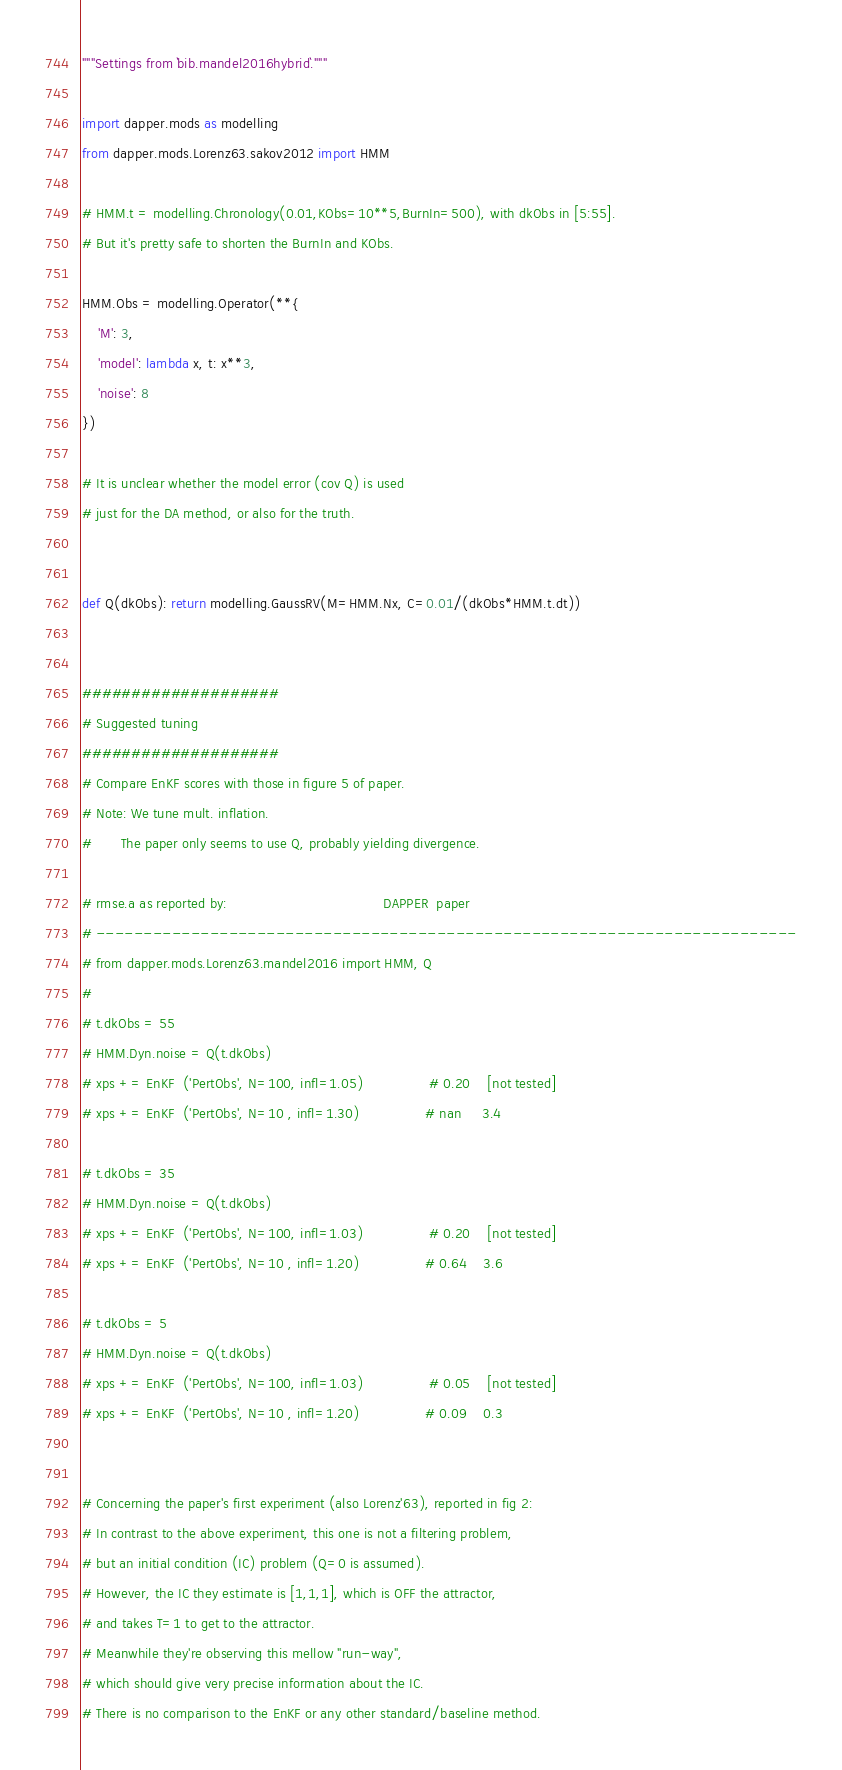Convert code to text. <code><loc_0><loc_0><loc_500><loc_500><_Python_>"""Settings from `bib.mandel2016hybrid`."""

import dapper.mods as modelling
from dapper.mods.Lorenz63.sakov2012 import HMM

# HMM.t = modelling.Chronology(0.01,KObs=10**5,BurnIn=500), with dkObs in [5:55].
# But it's pretty safe to shorten the BurnIn and KObs.

HMM.Obs = modelling.Operator(**{
    'M': 3,
    'model': lambda x, t: x**3,
    'noise': 8
})

# It is unclear whether the model error (cov Q) is used
# just for the DA method, or also for the truth.


def Q(dkObs): return modelling.GaussRV(M=HMM.Nx, C=0.01/(dkObs*HMM.t.dt))


####################
# Suggested tuning
####################
# Compare EnKF scores with those in figure 5 of paper.
# Note: We tune mult. inflation.
#       The paper only seems to use Q, probably yielding divergence.

# rmse.a as reported by:                                      DAPPER  paper
# --------------------------------------------------------------------------
# from dapper.mods.Lorenz63.mandel2016 import HMM, Q
#
# t.dkObs = 55
# HMM.Dyn.noise = Q(t.dkObs)
# xps += EnKF  ('PertObs', N=100, infl=1.05)                # 0.20    [not tested]
# xps += EnKF  ('PertObs', N=10 , infl=1.30)                # nan     3.4

# t.dkObs = 35
# HMM.Dyn.noise = Q(t.dkObs)
# xps += EnKF  ('PertObs', N=100, infl=1.03)                # 0.20    [not tested]
# xps += EnKF  ('PertObs', N=10 , infl=1.20)                # 0.64    3.6

# t.dkObs = 5
# HMM.Dyn.noise = Q(t.dkObs)
# xps += EnKF  ('PertObs', N=100, infl=1.03)                # 0.05    [not tested]
# xps += EnKF  ('PertObs', N=10 , infl=1.20)                # 0.09    0.3


# Concerning the paper's first experiment (also Lorenz'63), reported in fig 2:
# In contrast to the above experiment, this one is not a filtering problem,
# but an initial condition (IC) problem (Q=0 is assumed).
# However, the IC they estimate is [1,1,1], which is OFF the attractor,
# and takes T=1 to get to the attractor.
# Meanwhile they're observing this mellow "run-way",
# which should give very precise information about the IC.
# There is no comparison to the EnKF or any other standard/baseline method.
</code> 